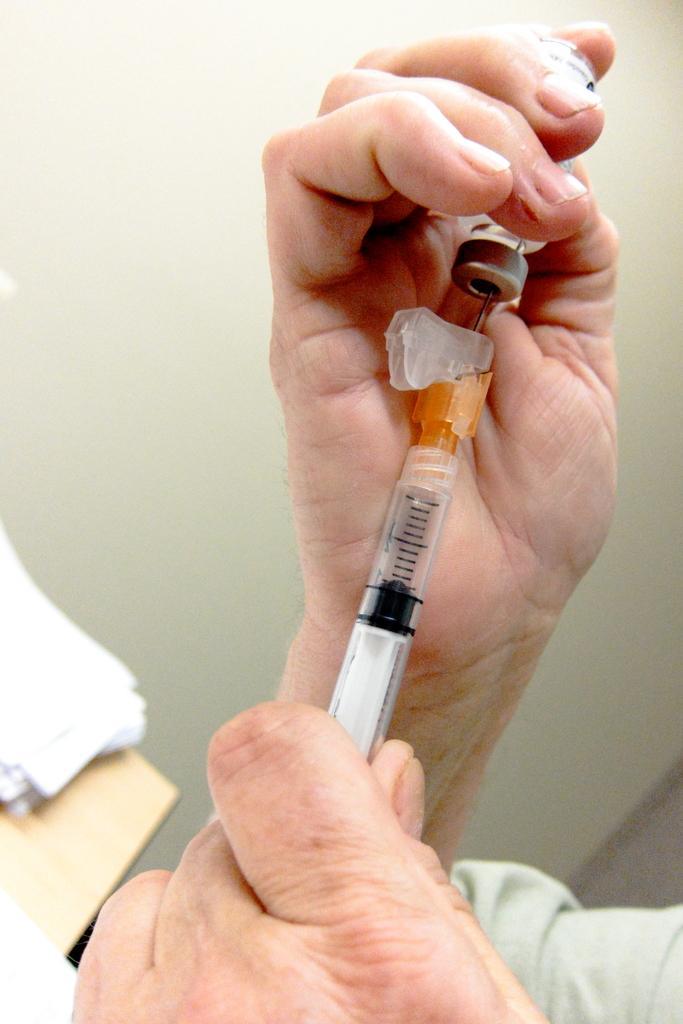Please provide a concise description of this image. In this image I can see hands of a person is holding an injection. I can also see a bottle over here. In the background I can also see few white colour things and I can see this image is little bit blurry from background. 